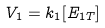Convert formula to latex. <formula><loc_0><loc_0><loc_500><loc_500>V _ { 1 } = k _ { 1 } [ E _ { 1 T } ]</formula> 